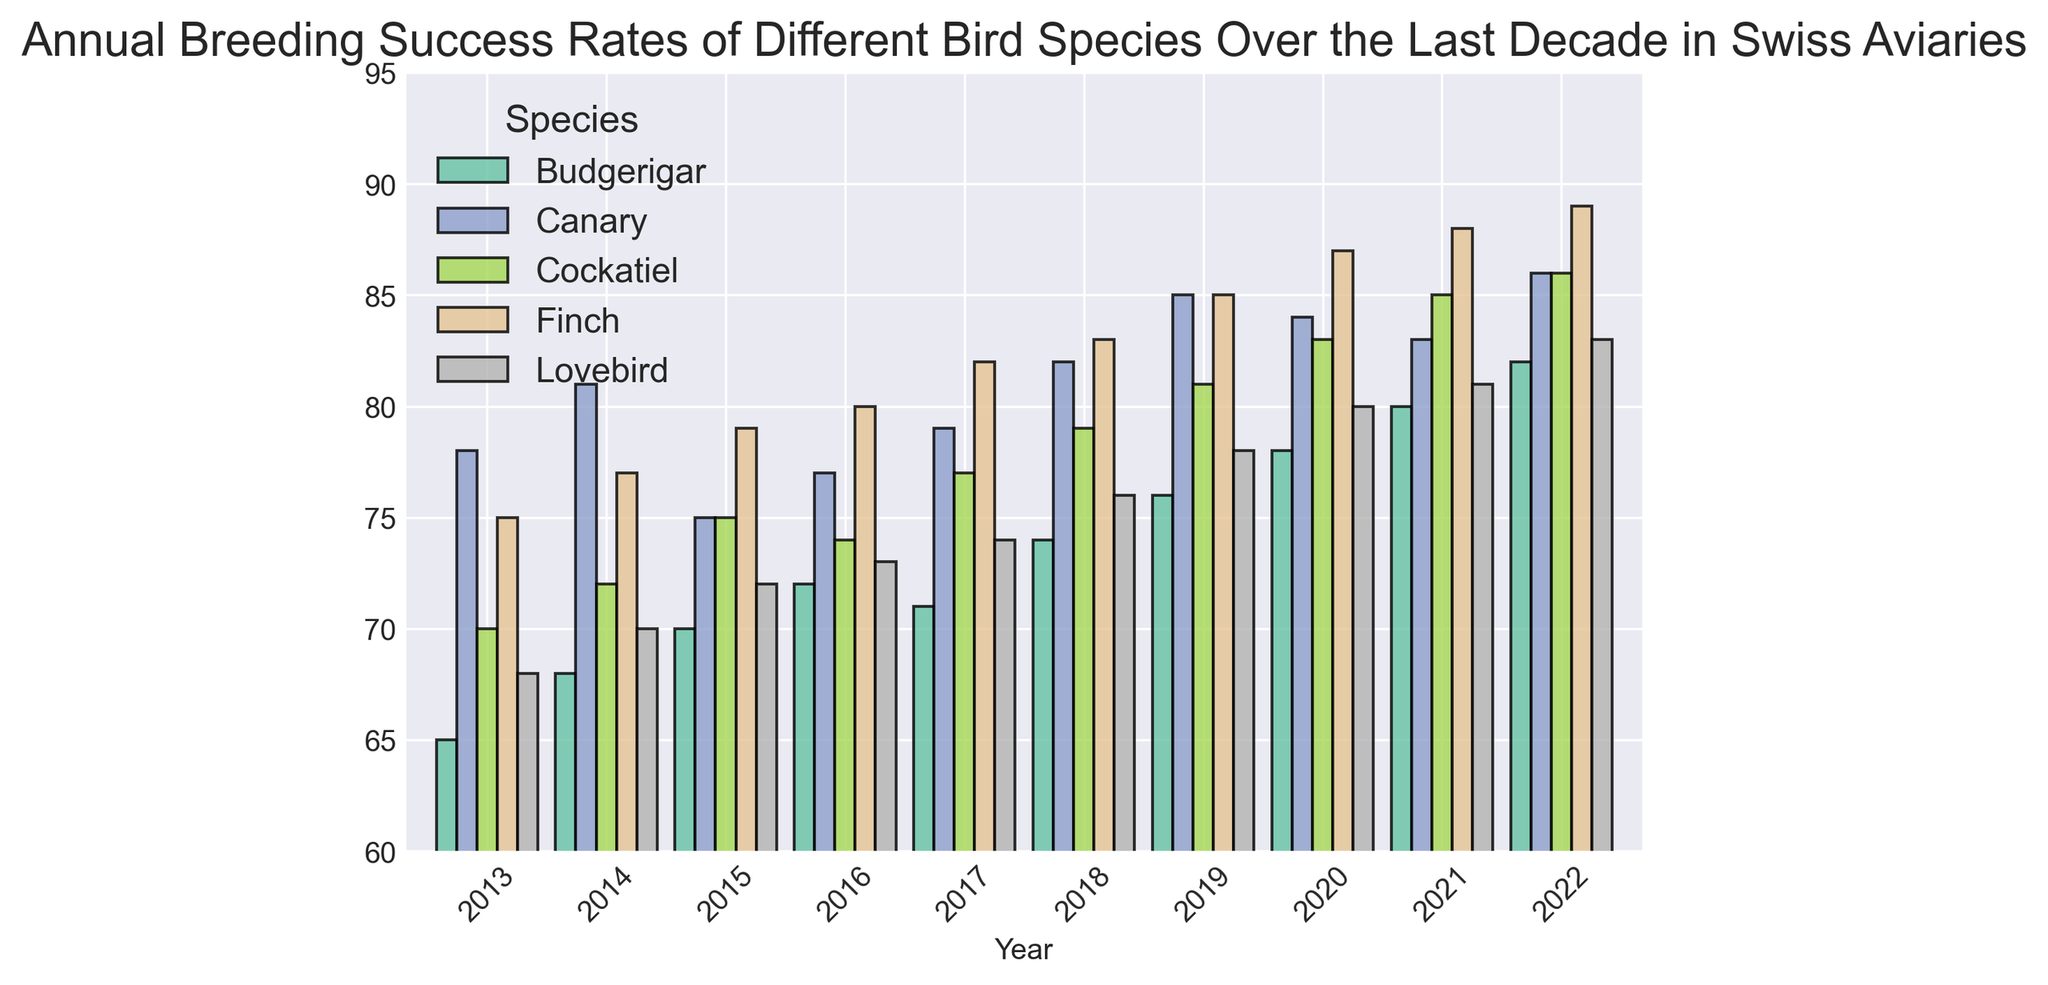Which species had the highest breeding success rate in 2022? To answer this, look at the height of the bars for 2022 in the figure. The species with the tallest bar represents the highest breeding success rate.
Answer: Finch What's the average breeding success rate of Canaries over the last decade? To find this, sum the breeding success rates of Canaries from 2013 to 2022 and divide by the number of years (10). (78 + 81 + 75 + 77 + 79 + 82 + 85 + 84 + 83 + 86) / 10 = 81
Answer: 81 Which species showed the most significant improvement in breeding success rate from 2013 to 2022? Compare the difference in breeding success rates between 2013 and 2022 for each species. The species with the largest positive difference is the one with the most significant improvement. Finch went from 75 to 89, an increase of 14.
Answer: Finch In which year did Budgerigars have the lowest breeding success rate, and what was that rate? Find the shortest bar representing Budgerigars across all years. The year associated with this bar is the one with the lowest rate. In 2013, the rate was 65.
Answer: 2013, 65 Compare the breeding success rates of Lovebirds and Cockatiels in 2019. Which species had a higher rate and by how much? Look at the bars for both species in 2019. Cockatiels had a rate of 81, and Lovebirds had 78. The difference is 81 - 78.
Answer: Cockatiel by 3 What is the trend in Finch breeding success rates over the last decade? Examine the bars corresponding to Finch from 2013 to 2022. The heights of these bars generally increase over time, indicating an upward trend.
Answer: Upward trend Which species had a constant increase in breeding success rate without any decline throughout the decade? Look for species where the bar heights for each year continually increase without any dips.
Answer: Finch In which year did Cockatiels achieve a breeding success rate of 85%? Look for the bar corresponding to Cockatiels that reaches the 85% mark. The year associated with this bar is 2021.
Answer: 2021 How does the breeding success rate of Lovebirds in 2020 compare to that of Canaries in 2016? Find the bars corresponding to Lovebirds in 2020 and Canaries in 2016. Lovebirds had a rate of 80%, while Canaries had 77%.
Answer: Lovebirds are higher by 3% What's the difference between the highest and lowest breeding success rates of any single species over the entire decade? Determine the highest and lowest breeding success rates for each species. The difference for Finch is the greatest: from 75 to 89. 89 - 75 = 14
Answer: 14 